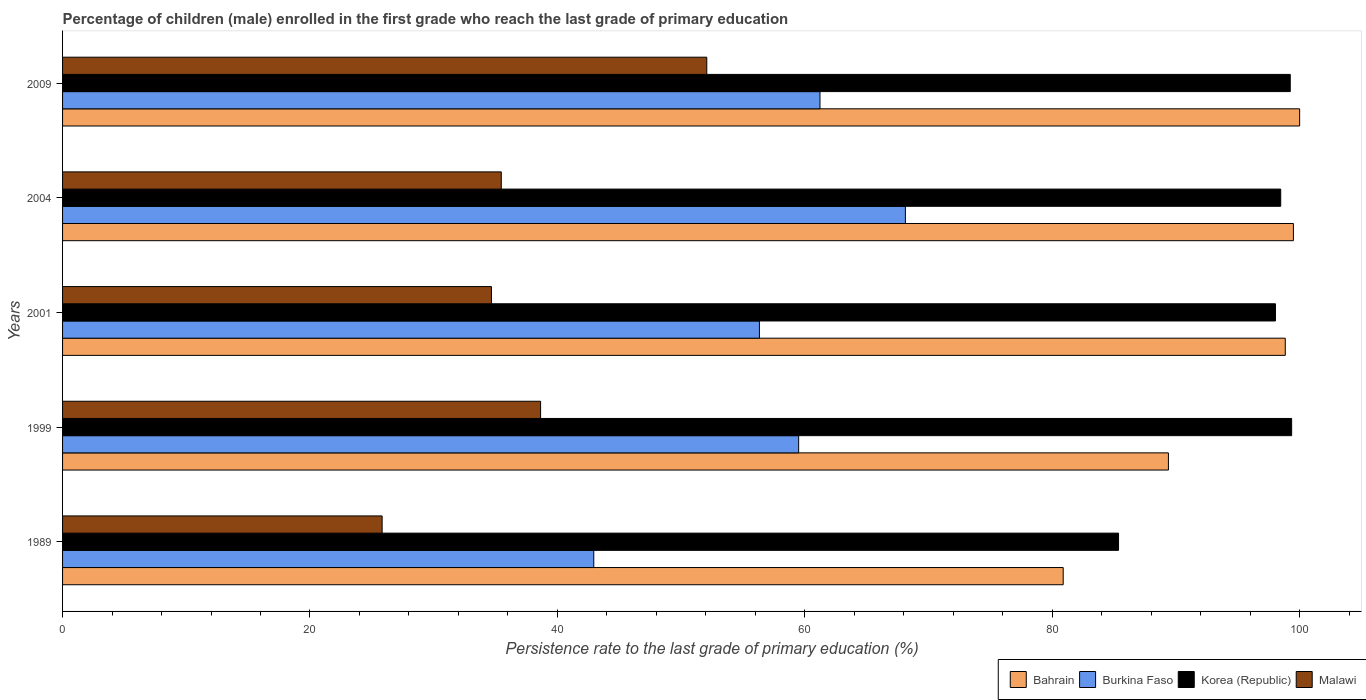How many different coloured bars are there?
Provide a succinct answer. 4. How many groups of bars are there?
Give a very brief answer. 5. Are the number of bars per tick equal to the number of legend labels?
Keep it short and to the point. Yes. How many bars are there on the 4th tick from the top?
Make the answer very short. 4. How many bars are there on the 2nd tick from the bottom?
Provide a succinct answer. 4. What is the label of the 3rd group of bars from the top?
Provide a succinct answer. 2001. What is the persistence rate of children in Burkina Faso in 1989?
Give a very brief answer. 42.94. Across all years, what is the maximum persistence rate of children in Korea (Republic)?
Your answer should be compact. 99.35. Across all years, what is the minimum persistence rate of children in Bahrain?
Offer a very short reply. 80.89. In which year was the persistence rate of children in Malawi minimum?
Offer a very short reply. 1989. What is the total persistence rate of children in Korea (Republic) in the graph?
Your answer should be compact. 480.47. What is the difference between the persistence rate of children in Bahrain in 2001 and that in 2004?
Your response must be concise. -0.66. What is the difference between the persistence rate of children in Burkina Faso in 1989 and the persistence rate of children in Korea (Republic) in 2001?
Your response must be concise. -55.1. What is the average persistence rate of children in Burkina Faso per year?
Give a very brief answer. 57.63. In the year 2004, what is the difference between the persistence rate of children in Burkina Faso and persistence rate of children in Bahrain?
Offer a terse response. -31.36. In how many years, is the persistence rate of children in Burkina Faso greater than 40 %?
Offer a terse response. 5. What is the ratio of the persistence rate of children in Malawi in 1989 to that in 1999?
Your response must be concise. 0.67. What is the difference between the highest and the second highest persistence rate of children in Korea (Republic)?
Make the answer very short. 0.11. What is the difference between the highest and the lowest persistence rate of children in Bahrain?
Your response must be concise. 19.11. Is the sum of the persistence rate of children in Malawi in 1989 and 2004 greater than the maximum persistence rate of children in Korea (Republic) across all years?
Keep it short and to the point. No. What does the 4th bar from the top in 2009 represents?
Give a very brief answer. Bahrain. What does the 2nd bar from the bottom in 1989 represents?
Ensure brevity in your answer.  Burkina Faso. Is it the case that in every year, the sum of the persistence rate of children in Malawi and persistence rate of children in Korea (Republic) is greater than the persistence rate of children in Bahrain?
Provide a succinct answer. Yes. How many years are there in the graph?
Make the answer very short. 5. Does the graph contain grids?
Offer a terse response. No. Where does the legend appear in the graph?
Give a very brief answer. Bottom right. How are the legend labels stacked?
Your answer should be very brief. Horizontal. What is the title of the graph?
Your answer should be very brief. Percentage of children (male) enrolled in the first grade who reach the last grade of primary education. What is the label or title of the X-axis?
Make the answer very short. Persistence rate to the last grade of primary education (%). What is the label or title of the Y-axis?
Your answer should be very brief. Years. What is the Persistence rate to the last grade of primary education (%) of Bahrain in 1989?
Your answer should be very brief. 80.89. What is the Persistence rate to the last grade of primary education (%) in Burkina Faso in 1989?
Your response must be concise. 42.94. What is the Persistence rate to the last grade of primary education (%) in Korea (Republic) in 1989?
Offer a terse response. 85.36. What is the Persistence rate to the last grade of primary education (%) of Malawi in 1989?
Make the answer very short. 25.83. What is the Persistence rate to the last grade of primary education (%) of Bahrain in 1999?
Offer a very short reply. 89.39. What is the Persistence rate to the last grade of primary education (%) of Burkina Faso in 1999?
Provide a succinct answer. 59.5. What is the Persistence rate to the last grade of primary education (%) in Korea (Republic) in 1999?
Offer a very short reply. 99.35. What is the Persistence rate to the last grade of primary education (%) of Malawi in 1999?
Provide a short and direct response. 38.64. What is the Persistence rate to the last grade of primary education (%) of Bahrain in 2001?
Your response must be concise. 98.84. What is the Persistence rate to the last grade of primary education (%) in Burkina Faso in 2001?
Your answer should be very brief. 56.33. What is the Persistence rate to the last grade of primary education (%) in Korea (Republic) in 2001?
Give a very brief answer. 98.05. What is the Persistence rate to the last grade of primary education (%) of Malawi in 2001?
Offer a very short reply. 34.67. What is the Persistence rate to the last grade of primary education (%) in Bahrain in 2004?
Give a very brief answer. 99.5. What is the Persistence rate to the last grade of primary education (%) in Burkina Faso in 2004?
Your answer should be very brief. 68.13. What is the Persistence rate to the last grade of primary education (%) of Korea (Republic) in 2004?
Provide a short and direct response. 98.47. What is the Persistence rate to the last grade of primary education (%) in Malawi in 2004?
Ensure brevity in your answer.  35.46. What is the Persistence rate to the last grade of primary education (%) in Bahrain in 2009?
Make the answer very short. 100. What is the Persistence rate to the last grade of primary education (%) of Burkina Faso in 2009?
Ensure brevity in your answer.  61.23. What is the Persistence rate to the last grade of primary education (%) in Korea (Republic) in 2009?
Offer a terse response. 99.24. What is the Persistence rate to the last grade of primary education (%) in Malawi in 2009?
Your response must be concise. 52.08. Across all years, what is the maximum Persistence rate to the last grade of primary education (%) of Bahrain?
Your answer should be very brief. 100. Across all years, what is the maximum Persistence rate to the last grade of primary education (%) in Burkina Faso?
Provide a succinct answer. 68.13. Across all years, what is the maximum Persistence rate to the last grade of primary education (%) in Korea (Republic)?
Your response must be concise. 99.35. Across all years, what is the maximum Persistence rate to the last grade of primary education (%) of Malawi?
Your answer should be compact. 52.08. Across all years, what is the minimum Persistence rate to the last grade of primary education (%) in Bahrain?
Provide a short and direct response. 80.89. Across all years, what is the minimum Persistence rate to the last grade of primary education (%) of Burkina Faso?
Your response must be concise. 42.94. Across all years, what is the minimum Persistence rate to the last grade of primary education (%) of Korea (Republic)?
Give a very brief answer. 85.36. Across all years, what is the minimum Persistence rate to the last grade of primary education (%) in Malawi?
Ensure brevity in your answer.  25.83. What is the total Persistence rate to the last grade of primary education (%) of Bahrain in the graph?
Your answer should be compact. 468.61. What is the total Persistence rate to the last grade of primary education (%) of Burkina Faso in the graph?
Give a very brief answer. 288.13. What is the total Persistence rate to the last grade of primary education (%) of Korea (Republic) in the graph?
Your response must be concise. 480.47. What is the total Persistence rate to the last grade of primary education (%) of Malawi in the graph?
Your response must be concise. 186.68. What is the difference between the Persistence rate to the last grade of primary education (%) in Bahrain in 1989 and that in 1999?
Make the answer very short. -8.51. What is the difference between the Persistence rate to the last grade of primary education (%) in Burkina Faso in 1989 and that in 1999?
Your answer should be compact. -16.56. What is the difference between the Persistence rate to the last grade of primary education (%) of Korea (Republic) in 1989 and that in 1999?
Make the answer very short. -13.99. What is the difference between the Persistence rate to the last grade of primary education (%) in Malawi in 1989 and that in 1999?
Keep it short and to the point. -12.81. What is the difference between the Persistence rate to the last grade of primary education (%) in Bahrain in 1989 and that in 2001?
Offer a very short reply. -17.95. What is the difference between the Persistence rate to the last grade of primary education (%) of Burkina Faso in 1989 and that in 2001?
Provide a short and direct response. -13.39. What is the difference between the Persistence rate to the last grade of primary education (%) in Korea (Republic) in 1989 and that in 2001?
Provide a short and direct response. -12.68. What is the difference between the Persistence rate to the last grade of primary education (%) in Malawi in 1989 and that in 2001?
Your response must be concise. -8.84. What is the difference between the Persistence rate to the last grade of primary education (%) in Bahrain in 1989 and that in 2004?
Provide a short and direct response. -18.61. What is the difference between the Persistence rate to the last grade of primary education (%) of Burkina Faso in 1989 and that in 2004?
Your response must be concise. -25.19. What is the difference between the Persistence rate to the last grade of primary education (%) of Korea (Republic) in 1989 and that in 2004?
Your response must be concise. -13.11. What is the difference between the Persistence rate to the last grade of primary education (%) of Malawi in 1989 and that in 2004?
Provide a succinct answer. -9.63. What is the difference between the Persistence rate to the last grade of primary education (%) in Bahrain in 1989 and that in 2009?
Ensure brevity in your answer.  -19.11. What is the difference between the Persistence rate to the last grade of primary education (%) of Burkina Faso in 1989 and that in 2009?
Offer a very short reply. -18.28. What is the difference between the Persistence rate to the last grade of primary education (%) of Korea (Republic) in 1989 and that in 2009?
Make the answer very short. -13.88. What is the difference between the Persistence rate to the last grade of primary education (%) of Malawi in 1989 and that in 2009?
Provide a succinct answer. -26.24. What is the difference between the Persistence rate to the last grade of primary education (%) in Bahrain in 1999 and that in 2001?
Keep it short and to the point. -9.45. What is the difference between the Persistence rate to the last grade of primary education (%) of Burkina Faso in 1999 and that in 2001?
Give a very brief answer. 3.17. What is the difference between the Persistence rate to the last grade of primary education (%) of Korea (Republic) in 1999 and that in 2001?
Make the answer very short. 1.31. What is the difference between the Persistence rate to the last grade of primary education (%) in Malawi in 1999 and that in 2001?
Make the answer very short. 3.97. What is the difference between the Persistence rate to the last grade of primary education (%) in Bahrain in 1999 and that in 2004?
Keep it short and to the point. -10.1. What is the difference between the Persistence rate to the last grade of primary education (%) in Burkina Faso in 1999 and that in 2004?
Your response must be concise. -8.63. What is the difference between the Persistence rate to the last grade of primary education (%) of Korea (Republic) in 1999 and that in 2004?
Provide a succinct answer. 0.88. What is the difference between the Persistence rate to the last grade of primary education (%) in Malawi in 1999 and that in 2004?
Your response must be concise. 3.18. What is the difference between the Persistence rate to the last grade of primary education (%) of Bahrain in 1999 and that in 2009?
Ensure brevity in your answer.  -10.61. What is the difference between the Persistence rate to the last grade of primary education (%) of Burkina Faso in 1999 and that in 2009?
Provide a succinct answer. -1.72. What is the difference between the Persistence rate to the last grade of primary education (%) in Korea (Republic) in 1999 and that in 2009?
Offer a terse response. 0.11. What is the difference between the Persistence rate to the last grade of primary education (%) of Malawi in 1999 and that in 2009?
Your answer should be very brief. -13.43. What is the difference between the Persistence rate to the last grade of primary education (%) in Bahrain in 2001 and that in 2004?
Make the answer very short. -0.66. What is the difference between the Persistence rate to the last grade of primary education (%) of Burkina Faso in 2001 and that in 2004?
Provide a succinct answer. -11.8. What is the difference between the Persistence rate to the last grade of primary education (%) of Korea (Republic) in 2001 and that in 2004?
Provide a short and direct response. -0.42. What is the difference between the Persistence rate to the last grade of primary education (%) in Malawi in 2001 and that in 2004?
Your response must be concise. -0.79. What is the difference between the Persistence rate to the last grade of primary education (%) of Bahrain in 2001 and that in 2009?
Ensure brevity in your answer.  -1.16. What is the difference between the Persistence rate to the last grade of primary education (%) in Burkina Faso in 2001 and that in 2009?
Keep it short and to the point. -4.9. What is the difference between the Persistence rate to the last grade of primary education (%) in Korea (Republic) in 2001 and that in 2009?
Give a very brief answer. -1.2. What is the difference between the Persistence rate to the last grade of primary education (%) of Malawi in 2001 and that in 2009?
Your answer should be very brief. -17.41. What is the difference between the Persistence rate to the last grade of primary education (%) in Bahrain in 2004 and that in 2009?
Provide a succinct answer. -0.5. What is the difference between the Persistence rate to the last grade of primary education (%) in Burkina Faso in 2004 and that in 2009?
Provide a succinct answer. 6.9. What is the difference between the Persistence rate to the last grade of primary education (%) of Korea (Republic) in 2004 and that in 2009?
Keep it short and to the point. -0.77. What is the difference between the Persistence rate to the last grade of primary education (%) in Malawi in 2004 and that in 2009?
Give a very brief answer. -16.61. What is the difference between the Persistence rate to the last grade of primary education (%) in Bahrain in 1989 and the Persistence rate to the last grade of primary education (%) in Burkina Faso in 1999?
Keep it short and to the point. 21.38. What is the difference between the Persistence rate to the last grade of primary education (%) of Bahrain in 1989 and the Persistence rate to the last grade of primary education (%) of Korea (Republic) in 1999?
Make the answer very short. -18.47. What is the difference between the Persistence rate to the last grade of primary education (%) of Bahrain in 1989 and the Persistence rate to the last grade of primary education (%) of Malawi in 1999?
Your response must be concise. 42.24. What is the difference between the Persistence rate to the last grade of primary education (%) in Burkina Faso in 1989 and the Persistence rate to the last grade of primary education (%) in Korea (Republic) in 1999?
Your response must be concise. -56.41. What is the difference between the Persistence rate to the last grade of primary education (%) in Burkina Faso in 1989 and the Persistence rate to the last grade of primary education (%) in Malawi in 1999?
Keep it short and to the point. 4.3. What is the difference between the Persistence rate to the last grade of primary education (%) of Korea (Republic) in 1989 and the Persistence rate to the last grade of primary education (%) of Malawi in 1999?
Give a very brief answer. 46.72. What is the difference between the Persistence rate to the last grade of primary education (%) in Bahrain in 1989 and the Persistence rate to the last grade of primary education (%) in Burkina Faso in 2001?
Your response must be concise. 24.56. What is the difference between the Persistence rate to the last grade of primary education (%) of Bahrain in 1989 and the Persistence rate to the last grade of primary education (%) of Korea (Republic) in 2001?
Offer a very short reply. -17.16. What is the difference between the Persistence rate to the last grade of primary education (%) in Bahrain in 1989 and the Persistence rate to the last grade of primary education (%) in Malawi in 2001?
Offer a terse response. 46.22. What is the difference between the Persistence rate to the last grade of primary education (%) in Burkina Faso in 1989 and the Persistence rate to the last grade of primary education (%) in Korea (Republic) in 2001?
Keep it short and to the point. -55.1. What is the difference between the Persistence rate to the last grade of primary education (%) in Burkina Faso in 1989 and the Persistence rate to the last grade of primary education (%) in Malawi in 2001?
Provide a short and direct response. 8.27. What is the difference between the Persistence rate to the last grade of primary education (%) of Korea (Republic) in 1989 and the Persistence rate to the last grade of primary education (%) of Malawi in 2001?
Make the answer very short. 50.69. What is the difference between the Persistence rate to the last grade of primary education (%) in Bahrain in 1989 and the Persistence rate to the last grade of primary education (%) in Burkina Faso in 2004?
Give a very brief answer. 12.76. What is the difference between the Persistence rate to the last grade of primary education (%) of Bahrain in 1989 and the Persistence rate to the last grade of primary education (%) of Korea (Republic) in 2004?
Make the answer very short. -17.58. What is the difference between the Persistence rate to the last grade of primary education (%) of Bahrain in 1989 and the Persistence rate to the last grade of primary education (%) of Malawi in 2004?
Your response must be concise. 45.42. What is the difference between the Persistence rate to the last grade of primary education (%) of Burkina Faso in 1989 and the Persistence rate to the last grade of primary education (%) of Korea (Republic) in 2004?
Your answer should be compact. -55.53. What is the difference between the Persistence rate to the last grade of primary education (%) of Burkina Faso in 1989 and the Persistence rate to the last grade of primary education (%) of Malawi in 2004?
Give a very brief answer. 7.48. What is the difference between the Persistence rate to the last grade of primary education (%) of Korea (Republic) in 1989 and the Persistence rate to the last grade of primary education (%) of Malawi in 2004?
Your response must be concise. 49.9. What is the difference between the Persistence rate to the last grade of primary education (%) of Bahrain in 1989 and the Persistence rate to the last grade of primary education (%) of Burkina Faso in 2009?
Keep it short and to the point. 19.66. What is the difference between the Persistence rate to the last grade of primary education (%) of Bahrain in 1989 and the Persistence rate to the last grade of primary education (%) of Korea (Republic) in 2009?
Give a very brief answer. -18.35. What is the difference between the Persistence rate to the last grade of primary education (%) in Bahrain in 1989 and the Persistence rate to the last grade of primary education (%) in Malawi in 2009?
Make the answer very short. 28.81. What is the difference between the Persistence rate to the last grade of primary education (%) in Burkina Faso in 1989 and the Persistence rate to the last grade of primary education (%) in Korea (Republic) in 2009?
Offer a terse response. -56.3. What is the difference between the Persistence rate to the last grade of primary education (%) of Burkina Faso in 1989 and the Persistence rate to the last grade of primary education (%) of Malawi in 2009?
Your answer should be very brief. -9.13. What is the difference between the Persistence rate to the last grade of primary education (%) in Korea (Republic) in 1989 and the Persistence rate to the last grade of primary education (%) in Malawi in 2009?
Ensure brevity in your answer.  33.29. What is the difference between the Persistence rate to the last grade of primary education (%) in Bahrain in 1999 and the Persistence rate to the last grade of primary education (%) in Burkina Faso in 2001?
Offer a terse response. 33.06. What is the difference between the Persistence rate to the last grade of primary education (%) of Bahrain in 1999 and the Persistence rate to the last grade of primary education (%) of Korea (Republic) in 2001?
Your answer should be compact. -8.65. What is the difference between the Persistence rate to the last grade of primary education (%) of Bahrain in 1999 and the Persistence rate to the last grade of primary education (%) of Malawi in 2001?
Your answer should be compact. 54.72. What is the difference between the Persistence rate to the last grade of primary education (%) in Burkina Faso in 1999 and the Persistence rate to the last grade of primary education (%) in Korea (Republic) in 2001?
Ensure brevity in your answer.  -38.54. What is the difference between the Persistence rate to the last grade of primary education (%) of Burkina Faso in 1999 and the Persistence rate to the last grade of primary education (%) of Malawi in 2001?
Give a very brief answer. 24.83. What is the difference between the Persistence rate to the last grade of primary education (%) in Korea (Republic) in 1999 and the Persistence rate to the last grade of primary education (%) in Malawi in 2001?
Ensure brevity in your answer.  64.68. What is the difference between the Persistence rate to the last grade of primary education (%) in Bahrain in 1999 and the Persistence rate to the last grade of primary education (%) in Burkina Faso in 2004?
Give a very brief answer. 21.26. What is the difference between the Persistence rate to the last grade of primary education (%) in Bahrain in 1999 and the Persistence rate to the last grade of primary education (%) in Korea (Republic) in 2004?
Provide a short and direct response. -9.08. What is the difference between the Persistence rate to the last grade of primary education (%) in Bahrain in 1999 and the Persistence rate to the last grade of primary education (%) in Malawi in 2004?
Provide a succinct answer. 53.93. What is the difference between the Persistence rate to the last grade of primary education (%) of Burkina Faso in 1999 and the Persistence rate to the last grade of primary education (%) of Korea (Republic) in 2004?
Provide a succinct answer. -38.97. What is the difference between the Persistence rate to the last grade of primary education (%) in Burkina Faso in 1999 and the Persistence rate to the last grade of primary education (%) in Malawi in 2004?
Provide a short and direct response. 24.04. What is the difference between the Persistence rate to the last grade of primary education (%) in Korea (Republic) in 1999 and the Persistence rate to the last grade of primary education (%) in Malawi in 2004?
Offer a terse response. 63.89. What is the difference between the Persistence rate to the last grade of primary education (%) of Bahrain in 1999 and the Persistence rate to the last grade of primary education (%) of Burkina Faso in 2009?
Your answer should be compact. 28.17. What is the difference between the Persistence rate to the last grade of primary education (%) in Bahrain in 1999 and the Persistence rate to the last grade of primary education (%) in Korea (Republic) in 2009?
Provide a short and direct response. -9.85. What is the difference between the Persistence rate to the last grade of primary education (%) in Bahrain in 1999 and the Persistence rate to the last grade of primary education (%) in Malawi in 2009?
Offer a terse response. 37.32. What is the difference between the Persistence rate to the last grade of primary education (%) in Burkina Faso in 1999 and the Persistence rate to the last grade of primary education (%) in Korea (Republic) in 2009?
Your answer should be compact. -39.74. What is the difference between the Persistence rate to the last grade of primary education (%) of Burkina Faso in 1999 and the Persistence rate to the last grade of primary education (%) of Malawi in 2009?
Make the answer very short. 7.43. What is the difference between the Persistence rate to the last grade of primary education (%) of Korea (Republic) in 1999 and the Persistence rate to the last grade of primary education (%) of Malawi in 2009?
Provide a short and direct response. 47.28. What is the difference between the Persistence rate to the last grade of primary education (%) of Bahrain in 2001 and the Persistence rate to the last grade of primary education (%) of Burkina Faso in 2004?
Offer a very short reply. 30.71. What is the difference between the Persistence rate to the last grade of primary education (%) of Bahrain in 2001 and the Persistence rate to the last grade of primary education (%) of Korea (Republic) in 2004?
Your response must be concise. 0.37. What is the difference between the Persistence rate to the last grade of primary education (%) of Bahrain in 2001 and the Persistence rate to the last grade of primary education (%) of Malawi in 2004?
Your answer should be compact. 63.38. What is the difference between the Persistence rate to the last grade of primary education (%) of Burkina Faso in 2001 and the Persistence rate to the last grade of primary education (%) of Korea (Republic) in 2004?
Provide a short and direct response. -42.14. What is the difference between the Persistence rate to the last grade of primary education (%) in Burkina Faso in 2001 and the Persistence rate to the last grade of primary education (%) in Malawi in 2004?
Ensure brevity in your answer.  20.87. What is the difference between the Persistence rate to the last grade of primary education (%) of Korea (Republic) in 2001 and the Persistence rate to the last grade of primary education (%) of Malawi in 2004?
Ensure brevity in your answer.  62.58. What is the difference between the Persistence rate to the last grade of primary education (%) of Bahrain in 2001 and the Persistence rate to the last grade of primary education (%) of Burkina Faso in 2009?
Keep it short and to the point. 37.61. What is the difference between the Persistence rate to the last grade of primary education (%) of Bahrain in 2001 and the Persistence rate to the last grade of primary education (%) of Korea (Republic) in 2009?
Give a very brief answer. -0.4. What is the difference between the Persistence rate to the last grade of primary education (%) of Bahrain in 2001 and the Persistence rate to the last grade of primary education (%) of Malawi in 2009?
Offer a very short reply. 46.76. What is the difference between the Persistence rate to the last grade of primary education (%) in Burkina Faso in 2001 and the Persistence rate to the last grade of primary education (%) in Korea (Republic) in 2009?
Ensure brevity in your answer.  -42.91. What is the difference between the Persistence rate to the last grade of primary education (%) in Burkina Faso in 2001 and the Persistence rate to the last grade of primary education (%) in Malawi in 2009?
Make the answer very short. 4.26. What is the difference between the Persistence rate to the last grade of primary education (%) of Korea (Republic) in 2001 and the Persistence rate to the last grade of primary education (%) of Malawi in 2009?
Ensure brevity in your answer.  45.97. What is the difference between the Persistence rate to the last grade of primary education (%) in Bahrain in 2004 and the Persistence rate to the last grade of primary education (%) in Burkina Faso in 2009?
Your answer should be compact. 38.27. What is the difference between the Persistence rate to the last grade of primary education (%) in Bahrain in 2004 and the Persistence rate to the last grade of primary education (%) in Korea (Republic) in 2009?
Your answer should be compact. 0.26. What is the difference between the Persistence rate to the last grade of primary education (%) of Bahrain in 2004 and the Persistence rate to the last grade of primary education (%) of Malawi in 2009?
Your response must be concise. 47.42. What is the difference between the Persistence rate to the last grade of primary education (%) in Burkina Faso in 2004 and the Persistence rate to the last grade of primary education (%) in Korea (Republic) in 2009?
Your response must be concise. -31.11. What is the difference between the Persistence rate to the last grade of primary education (%) in Burkina Faso in 2004 and the Persistence rate to the last grade of primary education (%) in Malawi in 2009?
Your answer should be very brief. 16.06. What is the difference between the Persistence rate to the last grade of primary education (%) of Korea (Republic) in 2004 and the Persistence rate to the last grade of primary education (%) of Malawi in 2009?
Give a very brief answer. 46.39. What is the average Persistence rate to the last grade of primary education (%) in Bahrain per year?
Offer a terse response. 93.72. What is the average Persistence rate to the last grade of primary education (%) in Burkina Faso per year?
Keep it short and to the point. 57.63. What is the average Persistence rate to the last grade of primary education (%) of Korea (Republic) per year?
Ensure brevity in your answer.  96.09. What is the average Persistence rate to the last grade of primary education (%) in Malawi per year?
Offer a very short reply. 37.34. In the year 1989, what is the difference between the Persistence rate to the last grade of primary education (%) in Bahrain and Persistence rate to the last grade of primary education (%) in Burkina Faso?
Your response must be concise. 37.95. In the year 1989, what is the difference between the Persistence rate to the last grade of primary education (%) of Bahrain and Persistence rate to the last grade of primary education (%) of Korea (Republic)?
Your answer should be compact. -4.47. In the year 1989, what is the difference between the Persistence rate to the last grade of primary education (%) of Bahrain and Persistence rate to the last grade of primary education (%) of Malawi?
Provide a succinct answer. 55.06. In the year 1989, what is the difference between the Persistence rate to the last grade of primary education (%) in Burkina Faso and Persistence rate to the last grade of primary education (%) in Korea (Republic)?
Provide a short and direct response. -42.42. In the year 1989, what is the difference between the Persistence rate to the last grade of primary education (%) in Burkina Faso and Persistence rate to the last grade of primary education (%) in Malawi?
Give a very brief answer. 17.11. In the year 1989, what is the difference between the Persistence rate to the last grade of primary education (%) in Korea (Republic) and Persistence rate to the last grade of primary education (%) in Malawi?
Keep it short and to the point. 59.53. In the year 1999, what is the difference between the Persistence rate to the last grade of primary education (%) of Bahrain and Persistence rate to the last grade of primary education (%) of Burkina Faso?
Provide a short and direct response. 29.89. In the year 1999, what is the difference between the Persistence rate to the last grade of primary education (%) in Bahrain and Persistence rate to the last grade of primary education (%) in Korea (Republic)?
Keep it short and to the point. -9.96. In the year 1999, what is the difference between the Persistence rate to the last grade of primary education (%) of Bahrain and Persistence rate to the last grade of primary education (%) of Malawi?
Your answer should be very brief. 50.75. In the year 1999, what is the difference between the Persistence rate to the last grade of primary education (%) of Burkina Faso and Persistence rate to the last grade of primary education (%) of Korea (Republic)?
Ensure brevity in your answer.  -39.85. In the year 1999, what is the difference between the Persistence rate to the last grade of primary education (%) of Burkina Faso and Persistence rate to the last grade of primary education (%) of Malawi?
Offer a very short reply. 20.86. In the year 1999, what is the difference between the Persistence rate to the last grade of primary education (%) in Korea (Republic) and Persistence rate to the last grade of primary education (%) in Malawi?
Offer a terse response. 60.71. In the year 2001, what is the difference between the Persistence rate to the last grade of primary education (%) of Bahrain and Persistence rate to the last grade of primary education (%) of Burkina Faso?
Make the answer very short. 42.51. In the year 2001, what is the difference between the Persistence rate to the last grade of primary education (%) in Bahrain and Persistence rate to the last grade of primary education (%) in Korea (Republic)?
Offer a terse response. 0.79. In the year 2001, what is the difference between the Persistence rate to the last grade of primary education (%) in Bahrain and Persistence rate to the last grade of primary education (%) in Malawi?
Ensure brevity in your answer.  64.17. In the year 2001, what is the difference between the Persistence rate to the last grade of primary education (%) in Burkina Faso and Persistence rate to the last grade of primary education (%) in Korea (Republic)?
Provide a short and direct response. -41.71. In the year 2001, what is the difference between the Persistence rate to the last grade of primary education (%) in Burkina Faso and Persistence rate to the last grade of primary education (%) in Malawi?
Give a very brief answer. 21.66. In the year 2001, what is the difference between the Persistence rate to the last grade of primary education (%) of Korea (Republic) and Persistence rate to the last grade of primary education (%) of Malawi?
Ensure brevity in your answer.  63.38. In the year 2004, what is the difference between the Persistence rate to the last grade of primary education (%) in Bahrain and Persistence rate to the last grade of primary education (%) in Burkina Faso?
Your response must be concise. 31.36. In the year 2004, what is the difference between the Persistence rate to the last grade of primary education (%) of Bahrain and Persistence rate to the last grade of primary education (%) of Korea (Republic)?
Provide a succinct answer. 1.03. In the year 2004, what is the difference between the Persistence rate to the last grade of primary education (%) in Bahrain and Persistence rate to the last grade of primary education (%) in Malawi?
Keep it short and to the point. 64.03. In the year 2004, what is the difference between the Persistence rate to the last grade of primary education (%) of Burkina Faso and Persistence rate to the last grade of primary education (%) of Korea (Republic)?
Provide a short and direct response. -30.34. In the year 2004, what is the difference between the Persistence rate to the last grade of primary education (%) of Burkina Faso and Persistence rate to the last grade of primary education (%) of Malawi?
Provide a succinct answer. 32.67. In the year 2004, what is the difference between the Persistence rate to the last grade of primary education (%) of Korea (Republic) and Persistence rate to the last grade of primary education (%) of Malawi?
Offer a very short reply. 63.01. In the year 2009, what is the difference between the Persistence rate to the last grade of primary education (%) in Bahrain and Persistence rate to the last grade of primary education (%) in Burkina Faso?
Make the answer very short. 38.77. In the year 2009, what is the difference between the Persistence rate to the last grade of primary education (%) of Bahrain and Persistence rate to the last grade of primary education (%) of Korea (Republic)?
Provide a succinct answer. 0.76. In the year 2009, what is the difference between the Persistence rate to the last grade of primary education (%) in Bahrain and Persistence rate to the last grade of primary education (%) in Malawi?
Ensure brevity in your answer.  47.92. In the year 2009, what is the difference between the Persistence rate to the last grade of primary education (%) of Burkina Faso and Persistence rate to the last grade of primary education (%) of Korea (Republic)?
Your answer should be very brief. -38.01. In the year 2009, what is the difference between the Persistence rate to the last grade of primary education (%) of Burkina Faso and Persistence rate to the last grade of primary education (%) of Malawi?
Keep it short and to the point. 9.15. In the year 2009, what is the difference between the Persistence rate to the last grade of primary education (%) of Korea (Republic) and Persistence rate to the last grade of primary education (%) of Malawi?
Ensure brevity in your answer.  47.17. What is the ratio of the Persistence rate to the last grade of primary education (%) in Bahrain in 1989 to that in 1999?
Your answer should be compact. 0.9. What is the ratio of the Persistence rate to the last grade of primary education (%) of Burkina Faso in 1989 to that in 1999?
Your answer should be very brief. 0.72. What is the ratio of the Persistence rate to the last grade of primary education (%) of Korea (Republic) in 1989 to that in 1999?
Your response must be concise. 0.86. What is the ratio of the Persistence rate to the last grade of primary education (%) of Malawi in 1989 to that in 1999?
Make the answer very short. 0.67. What is the ratio of the Persistence rate to the last grade of primary education (%) in Bahrain in 1989 to that in 2001?
Keep it short and to the point. 0.82. What is the ratio of the Persistence rate to the last grade of primary education (%) of Burkina Faso in 1989 to that in 2001?
Ensure brevity in your answer.  0.76. What is the ratio of the Persistence rate to the last grade of primary education (%) of Korea (Republic) in 1989 to that in 2001?
Your answer should be very brief. 0.87. What is the ratio of the Persistence rate to the last grade of primary education (%) in Malawi in 1989 to that in 2001?
Provide a short and direct response. 0.75. What is the ratio of the Persistence rate to the last grade of primary education (%) in Bahrain in 1989 to that in 2004?
Offer a very short reply. 0.81. What is the ratio of the Persistence rate to the last grade of primary education (%) in Burkina Faso in 1989 to that in 2004?
Make the answer very short. 0.63. What is the ratio of the Persistence rate to the last grade of primary education (%) in Korea (Republic) in 1989 to that in 2004?
Offer a terse response. 0.87. What is the ratio of the Persistence rate to the last grade of primary education (%) of Malawi in 1989 to that in 2004?
Keep it short and to the point. 0.73. What is the ratio of the Persistence rate to the last grade of primary education (%) of Bahrain in 1989 to that in 2009?
Offer a terse response. 0.81. What is the ratio of the Persistence rate to the last grade of primary education (%) of Burkina Faso in 1989 to that in 2009?
Your answer should be compact. 0.7. What is the ratio of the Persistence rate to the last grade of primary education (%) in Korea (Republic) in 1989 to that in 2009?
Make the answer very short. 0.86. What is the ratio of the Persistence rate to the last grade of primary education (%) of Malawi in 1989 to that in 2009?
Offer a very short reply. 0.5. What is the ratio of the Persistence rate to the last grade of primary education (%) in Bahrain in 1999 to that in 2001?
Offer a terse response. 0.9. What is the ratio of the Persistence rate to the last grade of primary education (%) in Burkina Faso in 1999 to that in 2001?
Ensure brevity in your answer.  1.06. What is the ratio of the Persistence rate to the last grade of primary education (%) in Korea (Republic) in 1999 to that in 2001?
Offer a terse response. 1.01. What is the ratio of the Persistence rate to the last grade of primary education (%) in Malawi in 1999 to that in 2001?
Offer a terse response. 1.11. What is the ratio of the Persistence rate to the last grade of primary education (%) in Bahrain in 1999 to that in 2004?
Keep it short and to the point. 0.9. What is the ratio of the Persistence rate to the last grade of primary education (%) in Burkina Faso in 1999 to that in 2004?
Give a very brief answer. 0.87. What is the ratio of the Persistence rate to the last grade of primary education (%) in Korea (Republic) in 1999 to that in 2004?
Offer a very short reply. 1.01. What is the ratio of the Persistence rate to the last grade of primary education (%) in Malawi in 1999 to that in 2004?
Your answer should be compact. 1.09. What is the ratio of the Persistence rate to the last grade of primary education (%) of Bahrain in 1999 to that in 2009?
Give a very brief answer. 0.89. What is the ratio of the Persistence rate to the last grade of primary education (%) of Burkina Faso in 1999 to that in 2009?
Offer a very short reply. 0.97. What is the ratio of the Persistence rate to the last grade of primary education (%) of Korea (Republic) in 1999 to that in 2009?
Keep it short and to the point. 1. What is the ratio of the Persistence rate to the last grade of primary education (%) in Malawi in 1999 to that in 2009?
Keep it short and to the point. 0.74. What is the ratio of the Persistence rate to the last grade of primary education (%) of Burkina Faso in 2001 to that in 2004?
Keep it short and to the point. 0.83. What is the ratio of the Persistence rate to the last grade of primary education (%) in Korea (Republic) in 2001 to that in 2004?
Offer a very short reply. 1. What is the ratio of the Persistence rate to the last grade of primary education (%) in Malawi in 2001 to that in 2004?
Keep it short and to the point. 0.98. What is the ratio of the Persistence rate to the last grade of primary education (%) in Bahrain in 2001 to that in 2009?
Provide a succinct answer. 0.99. What is the ratio of the Persistence rate to the last grade of primary education (%) of Korea (Republic) in 2001 to that in 2009?
Your response must be concise. 0.99. What is the ratio of the Persistence rate to the last grade of primary education (%) in Malawi in 2001 to that in 2009?
Keep it short and to the point. 0.67. What is the ratio of the Persistence rate to the last grade of primary education (%) in Bahrain in 2004 to that in 2009?
Offer a terse response. 0.99. What is the ratio of the Persistence rate to the last grade of primary education (%) in Burkina Faso in 2004 to that in 2009?
Give a very brief answer. 1.11. What is the ratio of the Persistence rate to the last grade of primary education (%) in Malawi in 2004 to that in 2009?
Your response must be concise. 0.68. What is the difference between the highest and the second highest Persistence rate to the last grade of primary education (%) in Bahrain?
Your answer should be very brief. 0.5. What is the difference between the highest and the second highest Persistence rate to the last grade of primary education (%) in Burkina Faso?
Provide a succinct answer. 6.9. What is the difference between the highest and the second highest Persistence rate to the last grade of primary education (%) of Korea (Republic)?
Keep it short and to the point. 0.11. What is the difference between the highest and the second highest Persistence rate to the last grade of primary education (%) in Malawi?
Offer a terse response. 13.43. What is the difference between the highest and the lowest Persistence rate to the last grade of primary education (%) of Bahrain?
Ensure brevity in your answer.  19.11. What is the difference between the highest and the lowest Persistence rate to the last grade of primary education (%) of Burkina Faso?
Offer a terse response. 25.19. What is the difference between the highest and the lowest Persistence rate to the last grade of primary education (%) in Korea (Republic)?
Provide a short and direct response. 13.99. What is the difference between the highest and the lowest Persistence rate to the last grade of primary education (%) in Malawi?
Make the answer very short. 26.24. 